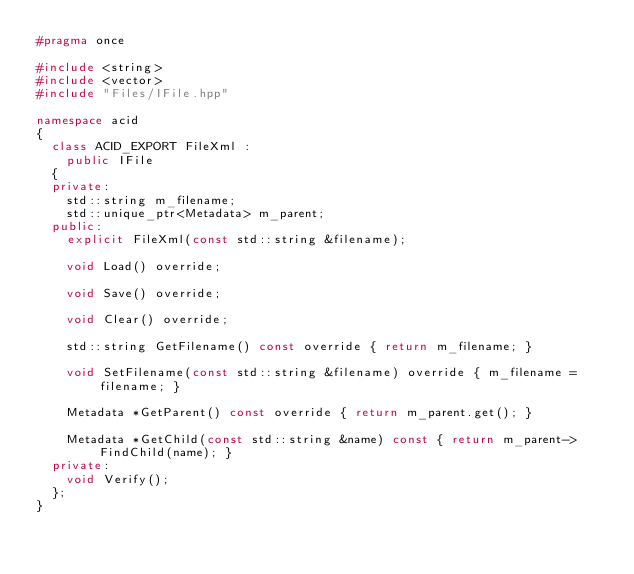Convert code to text. <code><loc_0><loc_0><loc_500><loc_500><_C++_>#pragma once

#include <string>
#include <vector>
#include "Files/IFile.hpp"

namespace acid
{
	class ACID_EXPORT FileXml :
		public IFile
	{
	private:
		std::string m_filename;
		std::unique_ptr<Metadata> m_parent;
	public:
		explicit FileXml(const std::string &filename);

		void Load() override;

		void Save() override;

		void Clear() override;

		std::string GetFilename() const override { return m_filename; }

		void SetFilename(const std::string &filename) override { m_filename = filename; }

		Metadata *GetParent() const override { return m_parent.get(); }

		Metadata *GetChild(const std::string &name) const { return m_parent->FindChild(name); }
	private:
		void Verify();
	};
}
</code> 